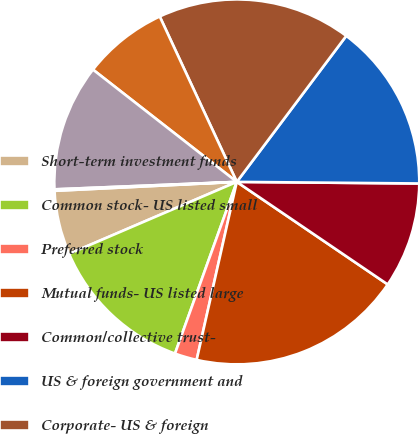<chart> <loc_0><loc_0><loc_500><loc_500><pie_chart><fcel>Short-term investment funds<fcel>Common stock- US listed small<fcel>Preferred stock<fcel>Mutual funds- US listed large<fcel>Common/collective trust-<fcel>US & foreign government and<fcel>Corporate- US & foreign<fcel>Corporate- US & foreign high<fcel>Multi-strategy hedge fund<fcel>Private equity fund<nl><fcel>5.67%<fcel>13.05%<fcel>1.97%<fcel>19.03%<fcel>9.36%<fcel>14.9%<fcel>17.18%<fcel>7.51%<fcel>11.2%<fcel>0.13%<nl></chart> 